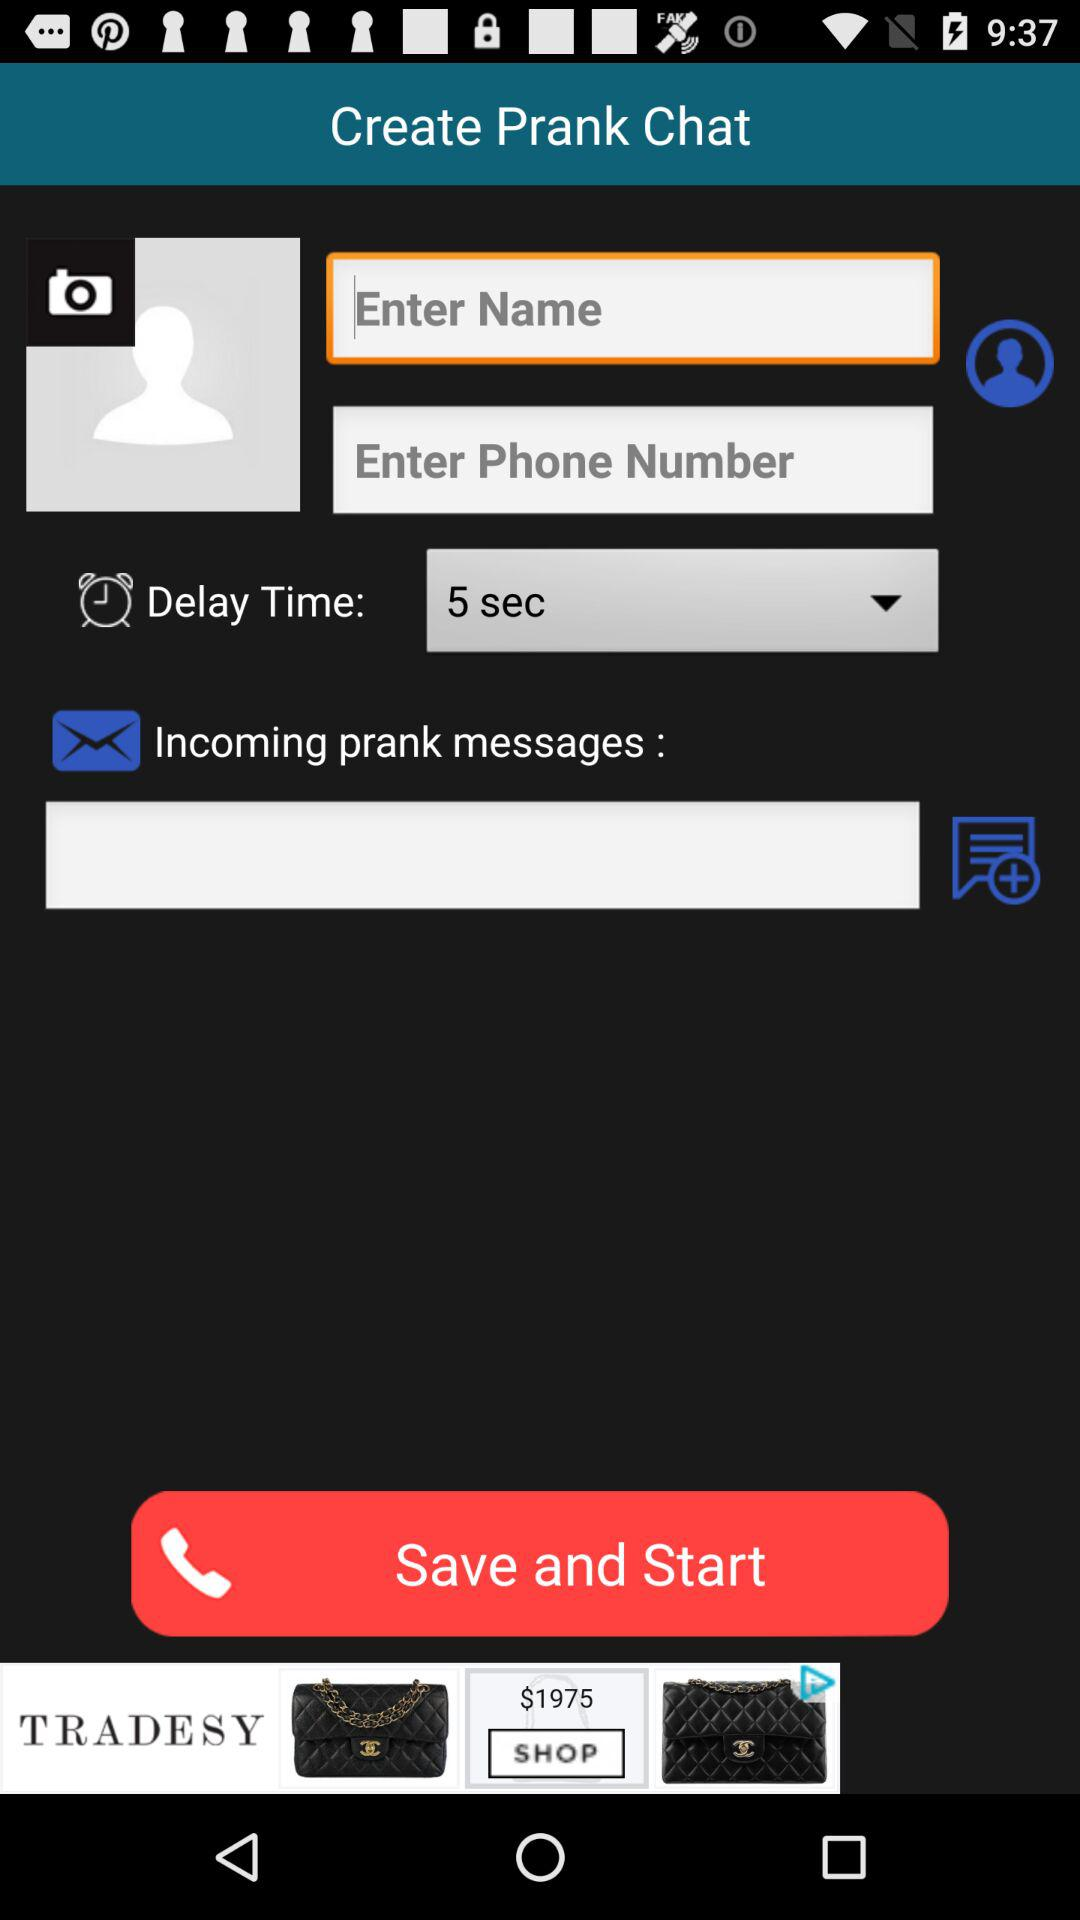What is the chosen delay time? The chosen delay time is 5 seconds. 